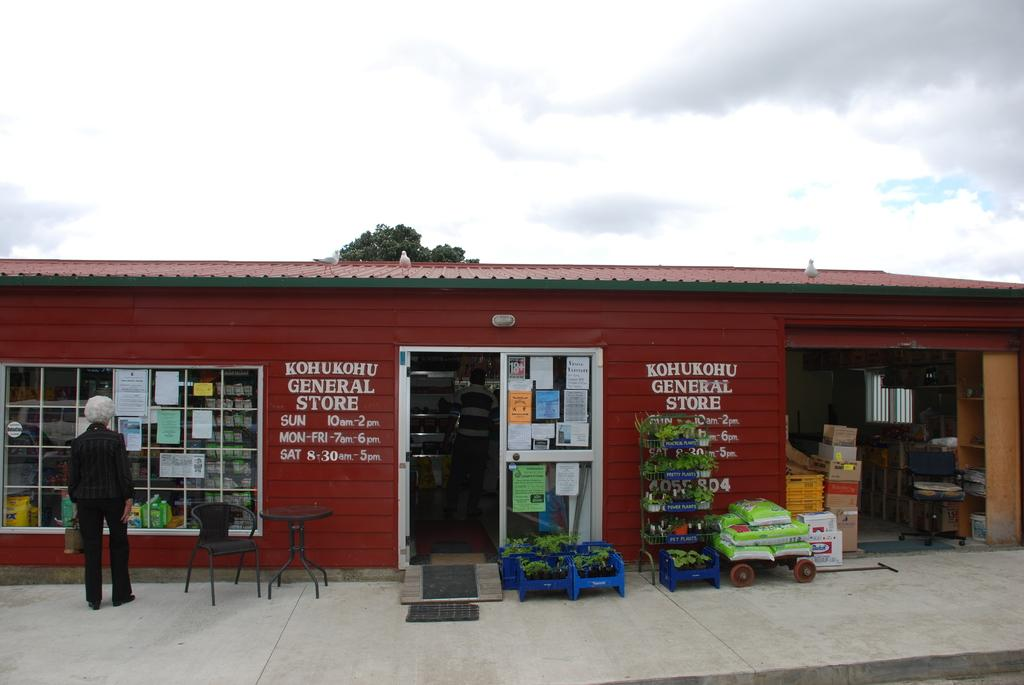<image>
Summarize the visual content of the image. Outside of the General Store that is painted red 